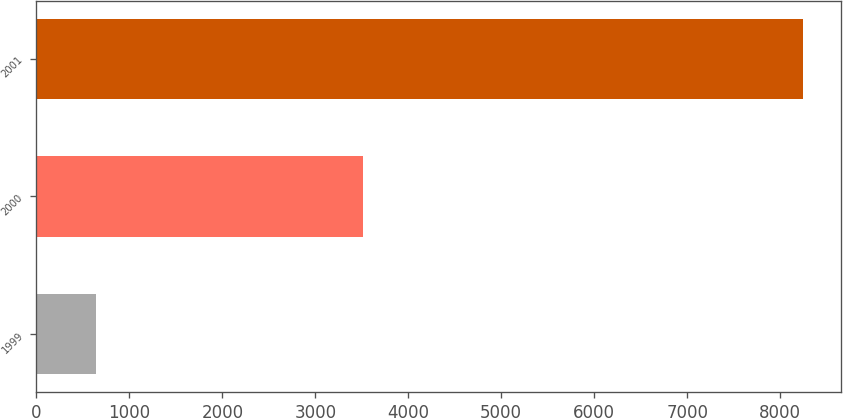Convert chart. <chart><loc_0><loc_0><loc_500><loc_500><bar_chart><fcel>1999<fcel>2000<fcel>2001<nl><fcel>645<fcel>3516<fcel>8248<nl></chart> 